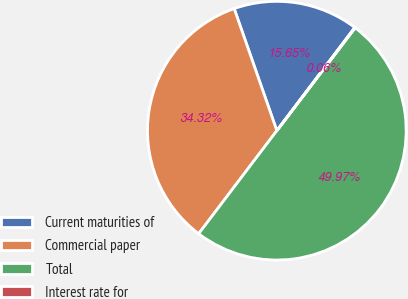<chart> <loc_0><loc_0><loc_500><loc_500><pie_chart><fcel>Current maturities of<fcel>Commercial paper<fcel>Total<fcel>Interest rate for<nl><fcel>15.65%<fcel>34.32%<fcel>49.97%<fcel>0.06%<nl></chart> 